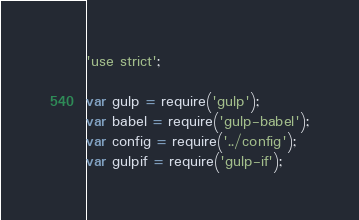Convert code to text. <code><loc_0><loc_0><loc_500><loc_500><_JavaScript_>'use strict';

var gulp = require('gulp');
var babel = require('gulp-babel');
var config = require('../config');
var gulpif = require('gulp-if');</code> 